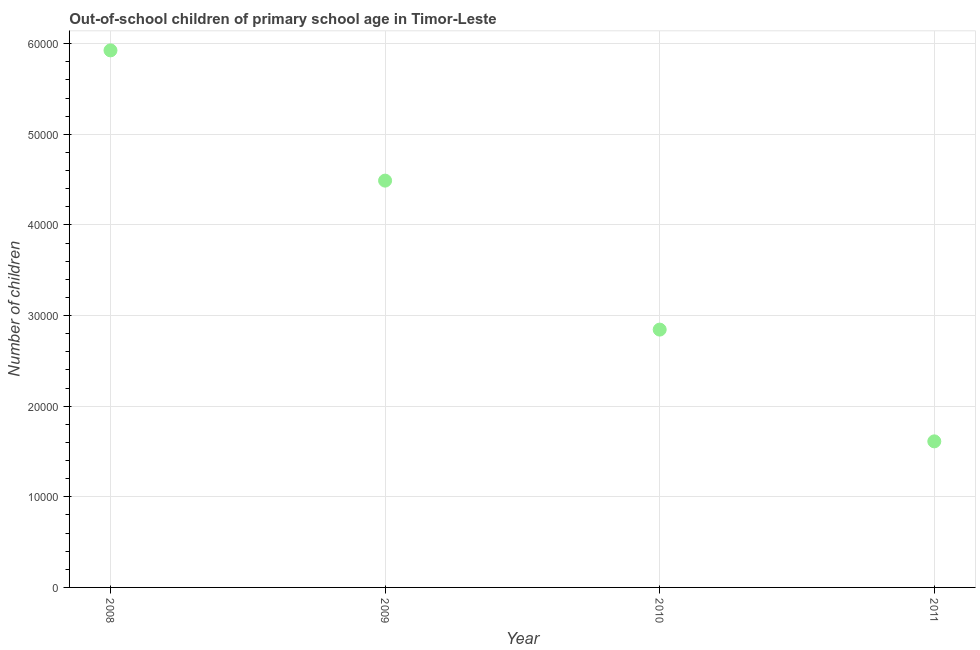What is the number of out-of-school children in 2008?
Provide a short and direct response. 5.93e+04. Across all years, what is the maximum number of out-of-school children?
Keep it short and to the point. 5.93e+04. Across all years, what is the minimum number of out-of-school children?
Your answer should be very brief. 1.61e+04. In which year was the number of out-of-school children maximum?
Offer a terse response. 2008. What is the sum of the number of out-of-school children?
Ensure brevity in your answer.  1.49e+05. What is the difference between the number of out-of-school children in 2009 and 2011?
Keep it short and to the point. 2.88e+04. What is the average number of out-of-school children per year?
Keep it short and to the point. 3.72e+04. What is the median number of out-of-school children?
Offer a very short reply. 3.67e+04. In how many years, is the number of out-of-school children greater than 40000 ?
Your response must be concise. 2. Do a majority of the years between 2011 and 2008 (inclusive) have number of out-of-school children greater than 14000 ?
Your answer should be compact. Yes. What is the ratio of the number of out-of-school children in 2010 to that in 2011?
Give a very brief answer. 1.77. Is the number of out-of-school children in 2008 less than that in 2010?
Offer a very short reply. No. Is the difference between the number of out-of-school children in 2008 and 2011 greater than the difference between any two years?
Make the answer very short. Yes. What is the difference between the highest and the second highest number of out-of-school children?
Keep it short and to the point. 1.44e+04. Is the sum of the number of out-of-school children in 2009 and 2011 greater than the maximum number of out-of-school children across all years?
Keep it short and to the point. Yes. What is the difference between the highest and the lowest number of out-of-school children?
Give a very brief answer. 4.31e+04. How many years are there in the graph?
Offer a very short reply. 4. What is the difference between two consecutive major ticks on the Y-axis?
Your response must be concise. 10000. Does the graph contain grids?
Provide a succinct answer. Yes. What is the title of the graph?
Make the answer very short. Out-of-school children of primary school age in Timor-Leste. What is the label or title of the X-axis?
Your response must be concise. Year. What is the label or title of the Y-axis?
Your answer should be very brief. Number of children. What is the Number of children in 2008?
Your answer should be very brief. 5.93e+04. What is the Number of children in 2009?
Provide a short and direct response. 4.49e+04. What is the Number of children in 2010?
Your answer should be compact. 2.84e+04. What is the Number of children in 2011?
Ensure brevity in your answer.  1.61e+04. What is the difference between the Number of children in 2008 and 2009?
Give a very brief answer. 1.44e+04. What is the difference between the Number of children in 2008 and 2010?
Ensure brevity in your answer.  3.08e+04. What is the difference between the Number of children in 2008 and 2011?
Provide a succinct answer. 4.31e+04. What is the difference between the Number of children in 2009 and 2010?
Your answer should be compact. 1.64e+04. What is the difference between the Number of children in 2009 and 2011?
Make the answer very short. 2.88e+04. What is the difference between the Number of children in 2010 and 2011?
Your response must be concise. 1.23e+04. What is the ratio of the Number of children in 2008 to that in 2009?
Give a very brief answer. 1.32. What is the ratio of the Number of children in 2008 to that in 2010?
Offer a terse response. 2.08. What is the ratio of the Number of children in 2008 to that in 2011?
Your answer should be very brief. 3.68. What is the ratio of the Number of children in 2009 to that in 2010?
Your answer should be compact. 1.58. What is the ratio of the Number of children in 2009 to that in 2011?
Make the answer very short. 2.79. What is the ratio of the Number of children in 2010 to that in 2011?
Offer a very short reply. 1.76. 